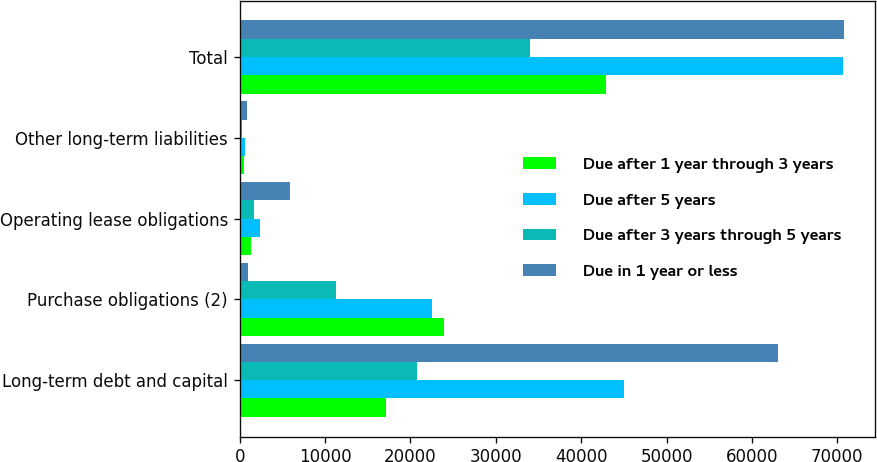Convert chart to OTSL. <chart><loc_0><loc_0><loc_500><loc_500><stacked_bar_chart><ecel><fcel>Long-term debt and capital<fcel>Purchase obligations (2)<fcel>Operating lease obligations<fcel>Other long-term liabilities<fcel>Total<nl><fcel>Due after 1 year through 3 years<fcel>17194<fcel>23918<fcel>1375<fcel>464<fcel>42951<nl><fcel>Due after 5 years<fcel>44962<fcel>22578<fcel>2410<fcel>676<fcel>70626<nl><fcel>Due after 3 years through 5 years<fcel>20799<fcel>11234<fcel>1732<fcel>290<fcel>34055<nl><fcel>Due in 1 year or less<fcel>63045<fcel>1005<fcel>5951<fcel>835<fcel>70836<nl></chart> 